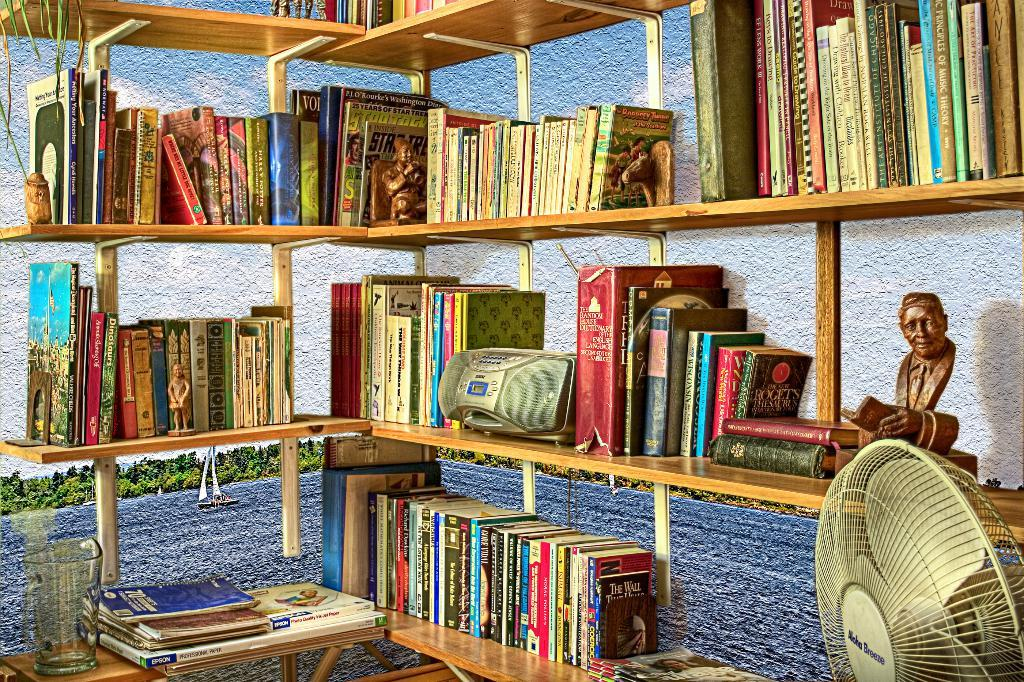What is the main object in the image that holds multiple items? There are many books on a wooden rack in the image. What type of container can be seen in the image? There is a glass jar in the image. What appliance is present in the image? There is a table fan in the image. What type of toys are visible in the image? There are statue toys in the image. What type of natural scenery is visible in the image? There are trees visible in the image. What type of ornament is hanging from the ceiling in the image? There is no ornament hanging from the ceiling in the image. What season is depicted in the image? The provided facts do not indicate a specific season, so it cannot be determined from the image. 